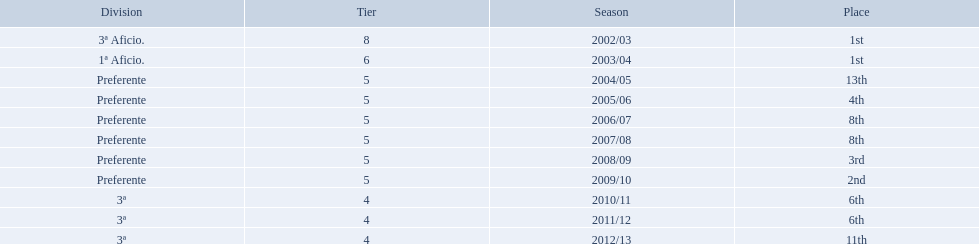What place did the team place in 2010/11? 6th. In what other year did they place 6th? 2011/12. 